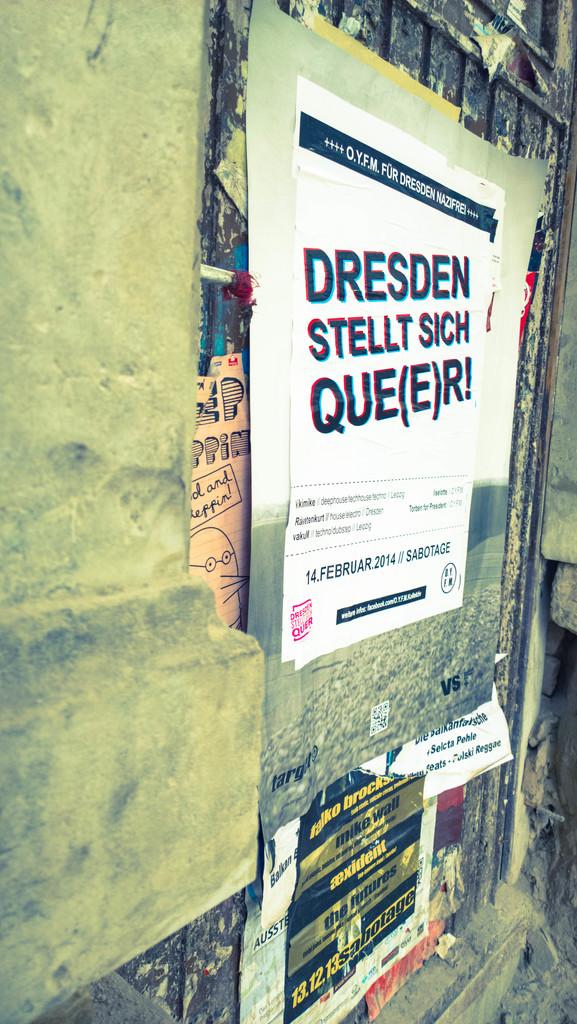What color is that writing on the white paper ?
Give a very brief answer. Black. 